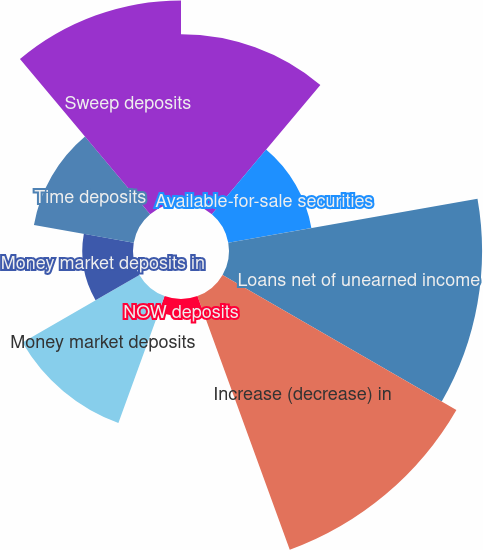Convert chart to OTSL. <chart><loc_0><loc_0><loc_500><loc_500><pie_chart><fcel>Federal funds sold securities<fcel>Available-for-sale securities<fcel>Loans net of unearned income<fcel>Increase (decrease) in<fcel>NOW deposits<fcel>Money market deposits<fcel>Money market deposits in<fcel>Time deposits<fcel>Sweep deposits<nl><fcel>13.16%<fcel>6.58%<fcel>19.73%<fcel>21.05%<fcel>1.32%<fcel>10.53%<fcel>3.95%<fcel>7.9%<fcel>15.79%<nl></chart> 